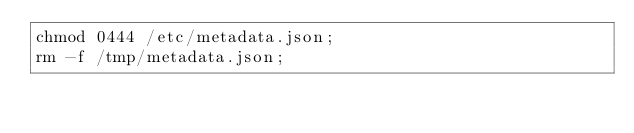Convert code to text. <code><loc_0><loc_0><loc_500><loc_500><_Bash_>chmod 0444 /etc/metadata.json;
rm -f /tmp/metadata.json;
</code> 